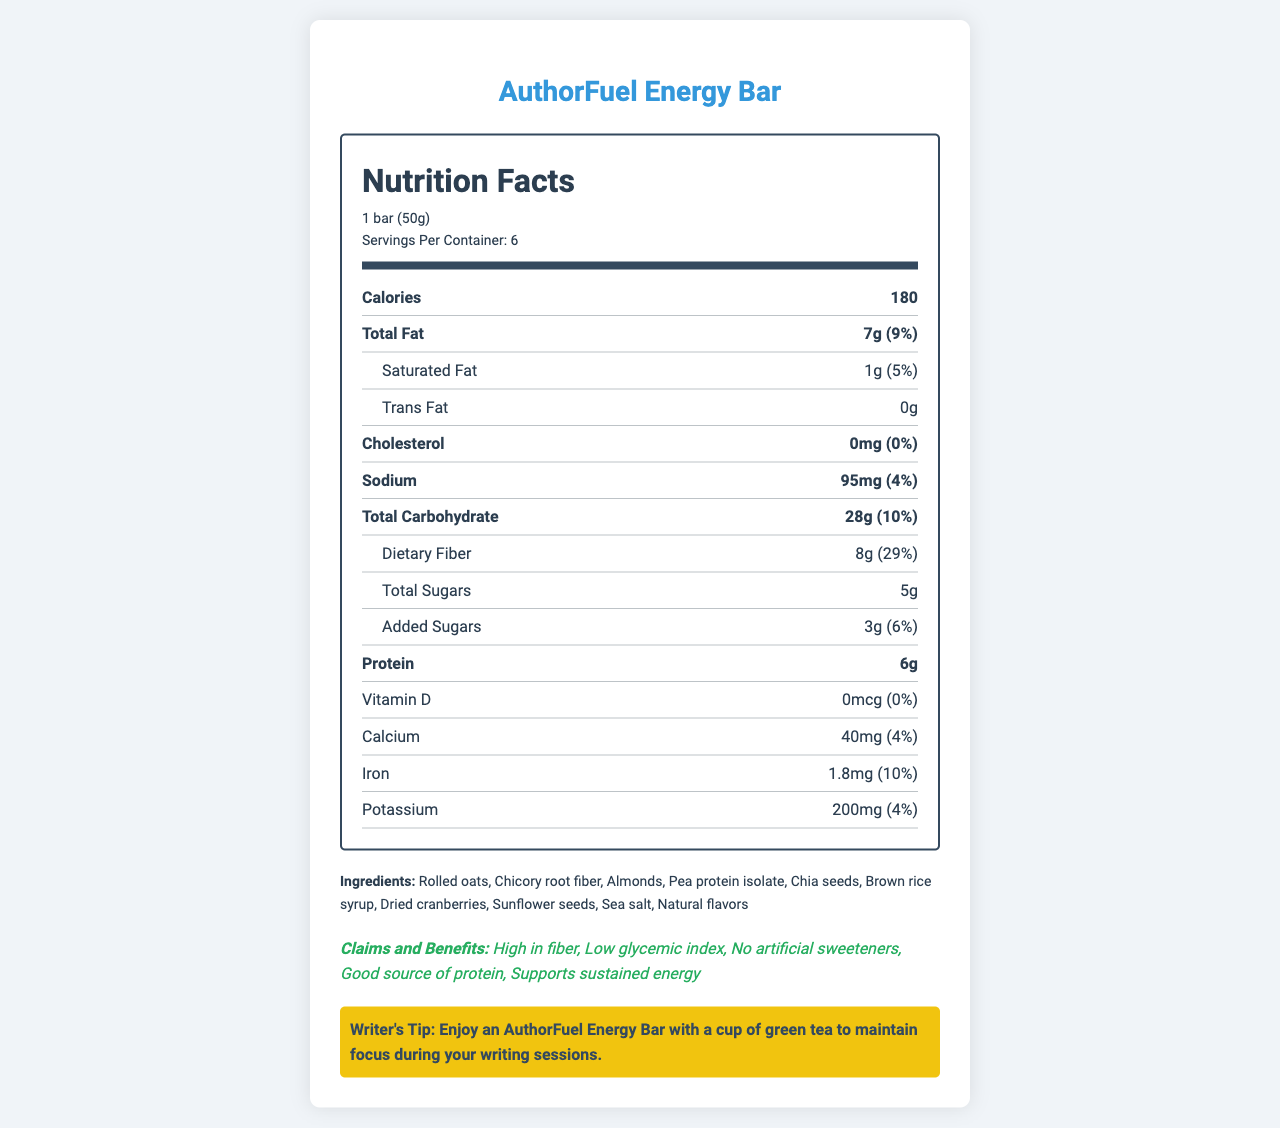what is the serving size of the AuthorFuel Energy Bar? The serving size is directly stated under the serving information section as "1 bar (50g)."
Answer: 1 bar (50g) how many calories are in one serving of the AuthorFuel Energy Bar? The calories per serving are listed as 180 in the bolded section right after the serving information.
Answer: 180 what ingredient in the AuthorFuel Energy Bar provides the highest percentage of daily value? The dietary fiber has a percent daily value of 29%, which is the highest among all listed daily values.
Answer: Dietary Fiber (29%) what is the total fat content per serving? The total fat content per serving is listed as "7g" in the bolded section of the nutrition label.
Answer: 7g what is the main benefit related to the glycemic index of the AuthorFuel Energy Bar? One of the claims and benefits of the product, as listed, is that it has a low glycemic index.
Answer: Low glycemic index which mineral provides the least percentage of the daily value? 
A. Calcium
B. Iron
C. Potassium
D. Sodium Calcium provides 4% of the daily value, which is lower compared to Iron (10%), Potassium (4%), and Sodium (4%).
Answer: A how much saturated fat is in one serving? 
I. 0g
II. 1g
III. 3g
IV. 7g The amount of saturated fat is listed as "1g" under the saturated fat section of the nutrition label.
Answer: II does the AuthorFuel Energy Bar contain artificial sweeteners? One of the claims and benefits is that there are no artificial sweeteners.
Answer: No does the AuthorFuel Energy Bar contain any peanuts? The allergen information states that it contains tree nuts (almonds) and may contain traces of peanuts and other tree nuts, but it does not confirm the presence of peanuts explicitly.
Answer: Not enough information summarize the main purpose of this document. The document highlights the nutritional benefits, ingredient details, and suggested use to help maintain focus and energy levels during writing. It includes essential nutrient values, serving size, allergen information, and storage instructions, along with a writer's tip for consuming the bar with green tea.
Answer: The document provides detailed nutritional information, ingredient list, claims and benefits, and consumption tips for the AuthorFuel Energy Bar, designed to support sustained energy for writing sessions. 